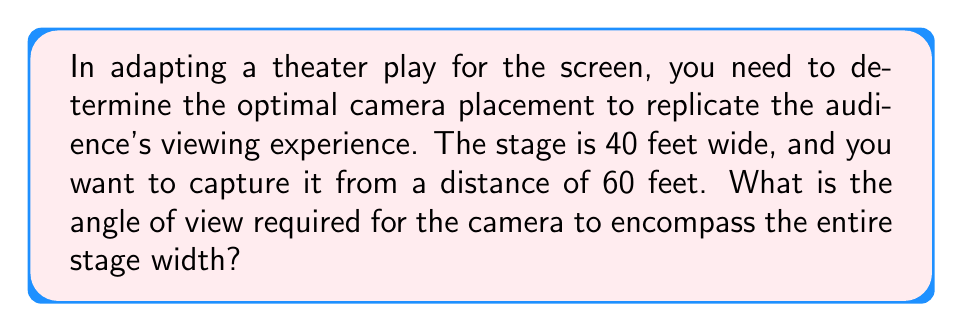Provide a solution to this math problem. To solve this problem, we can use basic trigonometry. The situation forms a triangle where:

1. The base of the triangle is the stage width (40 feet)
2. The height of the triangle is the distance from the camera to the stage (60 feet)
3. The angle we're looking for is at the vertex where the camera is positioned

We can use the arctangent function to find this angle. Here's the step-by-step solution:

1. The angle of view is twice the angle from the center of the stage to one edge.
2. Half the stage width is 40/2 = 20 feet.
3. We can now use the arctangent function:

   $$\theta = 2 * \arctan(\frac{\text{half stage width}}{\text{distance to stage}})$$

4. Plugging in our values:

   $$\theta = 2 * \arctan(\frac{20}{60})$$

5. Simplify:
   
   $$\theta = 2 * \arctan(\frac{1}{3})$$

6. Calculate:
   
   $$\theta \approx 2 * 18.43^\circ = 36.86^\circ$$

Therefore, the required angle of view is approximately 36.86°.

[asy]
import geometry;

pair A = (0,0), B = (40,0), C = (20,60);
draw(A--B--C--A);
draw(C--(20,0),dashed);

label("40 ft", (20,0), S);
label("60 ft", (30,30), NE);
label("θ", C, N);

dot("Camera", C, N);
dot("Stage Left", A, SW);
dot("Stage Right", B, SE);
[/asy]
Answer: 36.86° 